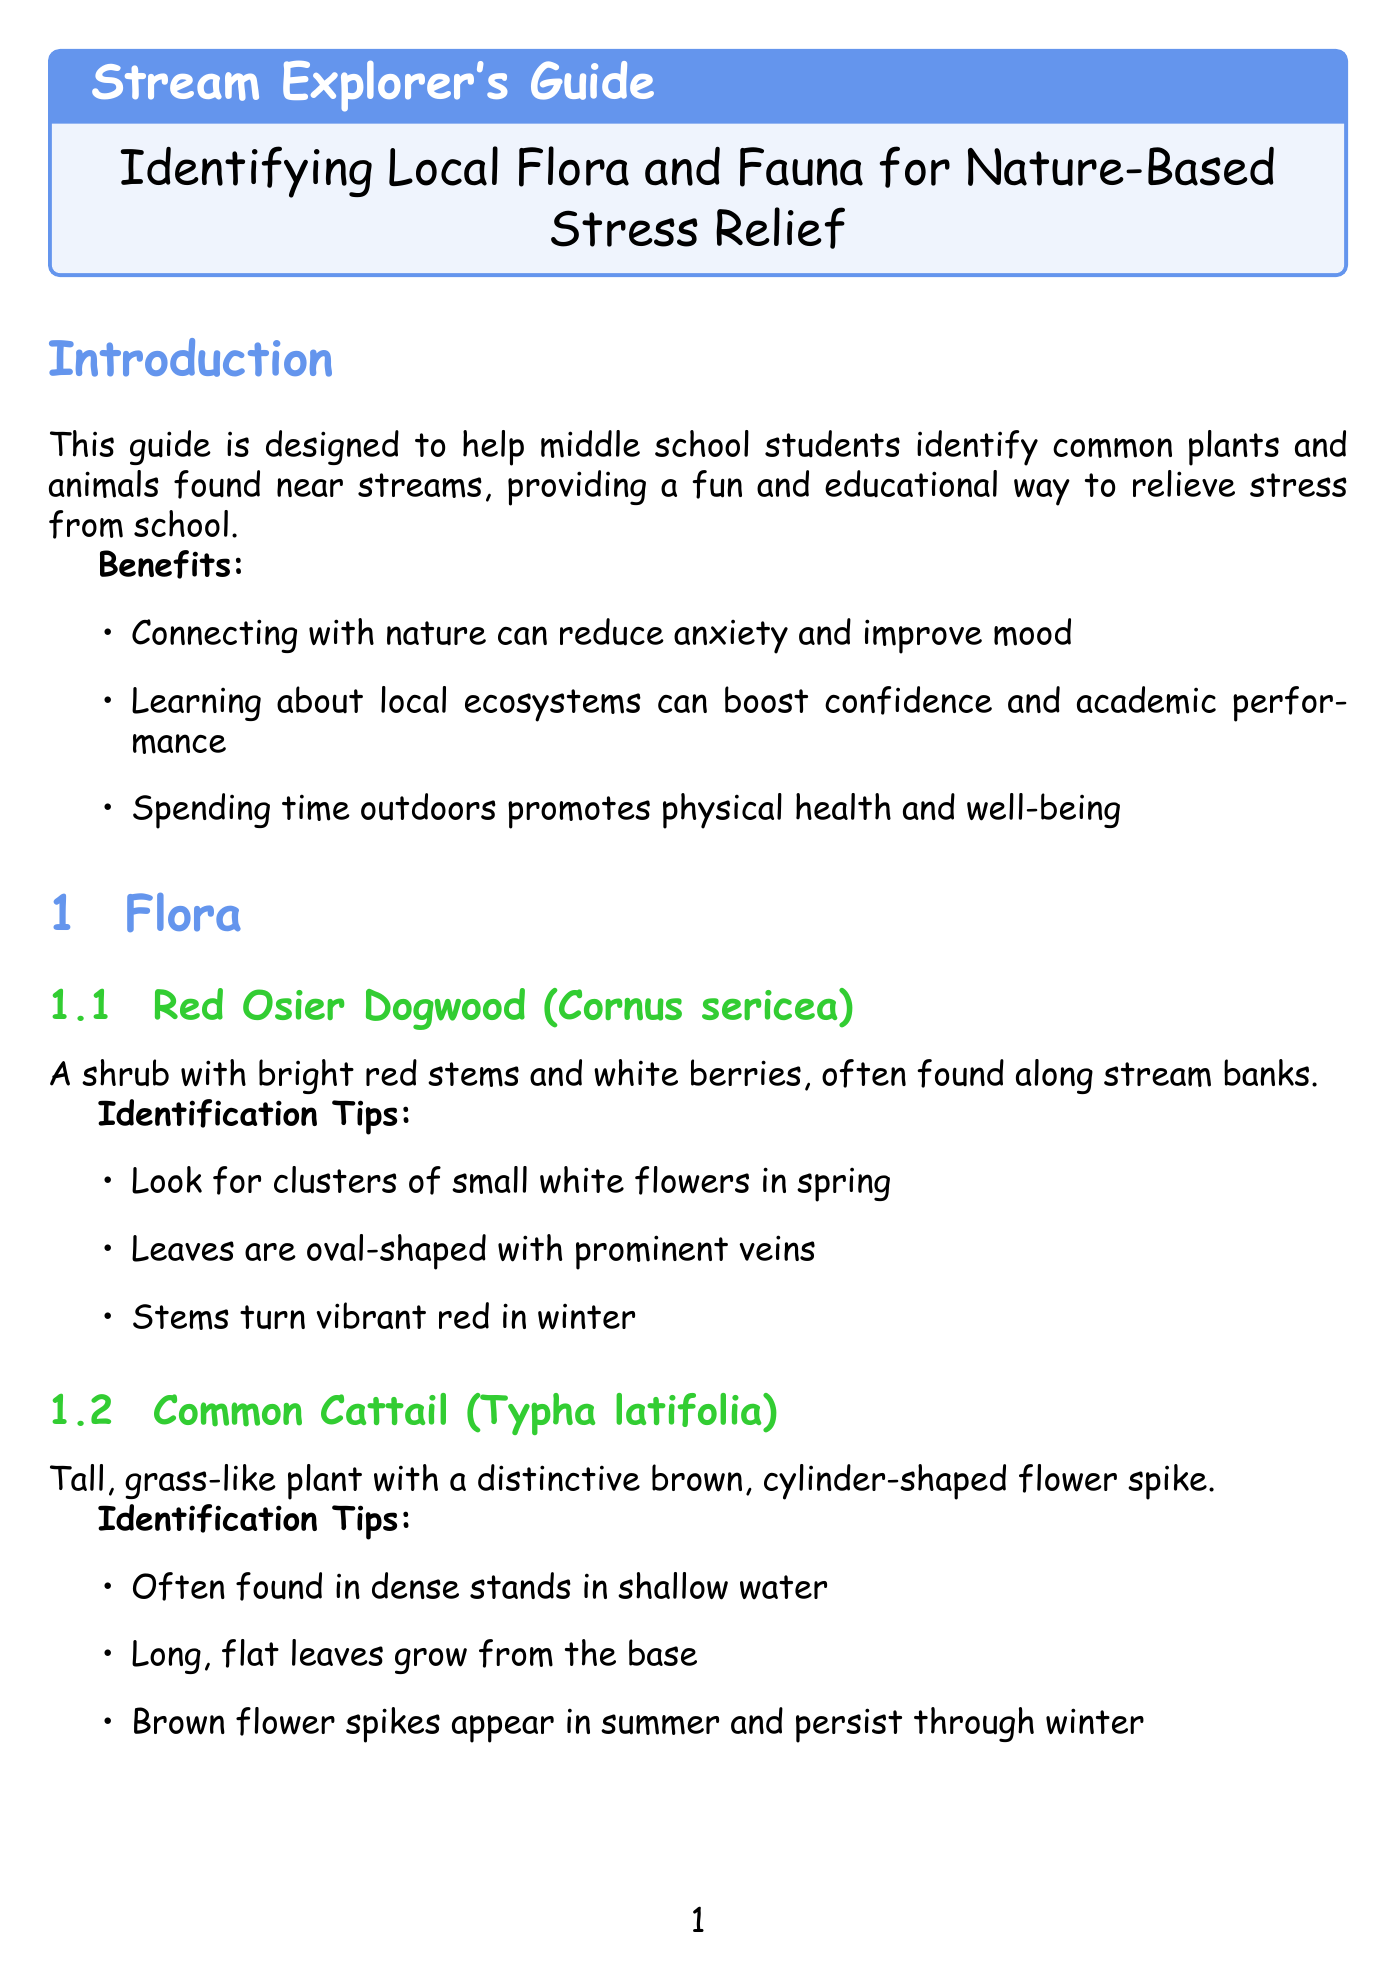what is the title of the guide? The title is provided in the header section of the document.
Answer: Stream Explorer's Guide: Identifying Local Flora and Fauna for Nature-Based Stress Relief how many flora are listed in the document? The number of flora entries is counted from the flora section.
Answer: 3 what is the scientific name of the Eastern Box Turtle? The scientific name is found in the description of the Eastern Box Turtle.
Answer: Terrapene carolina carolina what activity involves creating artwork? The activity descriptions mention what each activity entails.
Answer: Leaf Rubbing which plant should you avoid touching? The safety note mentions the plant that causes stinging.
Answer: Stinging Nettle what insect can walk on water? This information can be found in the fauna section describing the Water Strider.
Answer: Water Strider what is one benefit of connecting with nature? The benefits listed in the introduction provide reasons for connecting with nature.
Answer: Reduce anxiety what should you bring with you for safety? The safety guidelines section lists what to bring when visiting streams.
Answer: Water, snacks, and sun protection how many tips are provided for stress relief? The tips for stress relief can be counted in the stress relief tips section.
Answer: 4 